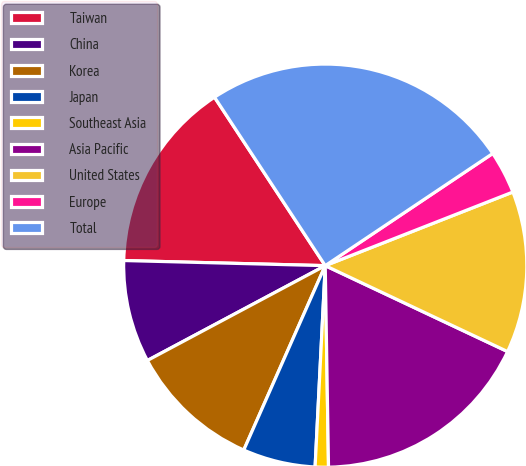<chart> <loc_0><loc_0><loc_500><loc_500><pie_chart><fcel>Taiwan<fcel>China<fcel>Korea<fcel>Japan<fcel>Southeast Asia<fcel>Asia Pacific<fcel>United States<fcel>Europe<fcel>Total<nl><fcel>15.34%<fcel>8.2%<fcel>10.58%<fcel>5.82%<fcel>1.06%<fcel>17.73%<fcel>12.96%<fcel>3.44%<fcel>24.86%<nl></chart> 